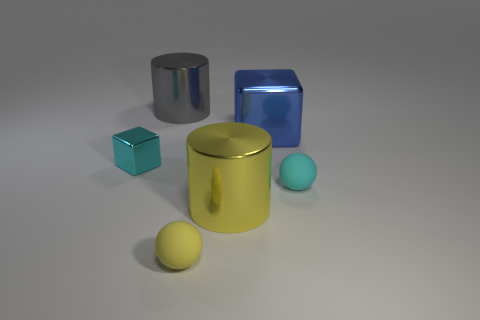There is another matte object that is the same shape as the yellow rubber object; what is its color?
Provide a short and direct response. Cyan. How many yellow objects are either matte things or large shiny things?
Offer a very short reply. 2. What is the material of the ball that is in front of the cylinder in front of the cyan block?
Provide a succinct answer. Rubber. Does the small cyan rubber object have the same shape as the big yellow shiny thing?
Offer a very short reply. No. What is the color of the matte ball that is the same size as the cyan matte thing?
Provide a short and direct response. Yellow. Is there a metal cylinder of the same color as the small shiny object?
Ensure brevity in your answer.  No. Are there any objects?
Make the answer very short. Yes. Is the material of the small cyan thing that is on the left side of the cyan ball the same as the big gray cylinder?
Keep it short and to the point. Yes. What size is the rubber sphere that is the same color as the tiny metal block?
Provide a short and direct response. Small. What number of blue objects have the same size as the yellow shiny object?
Offer a terse response. 1. 